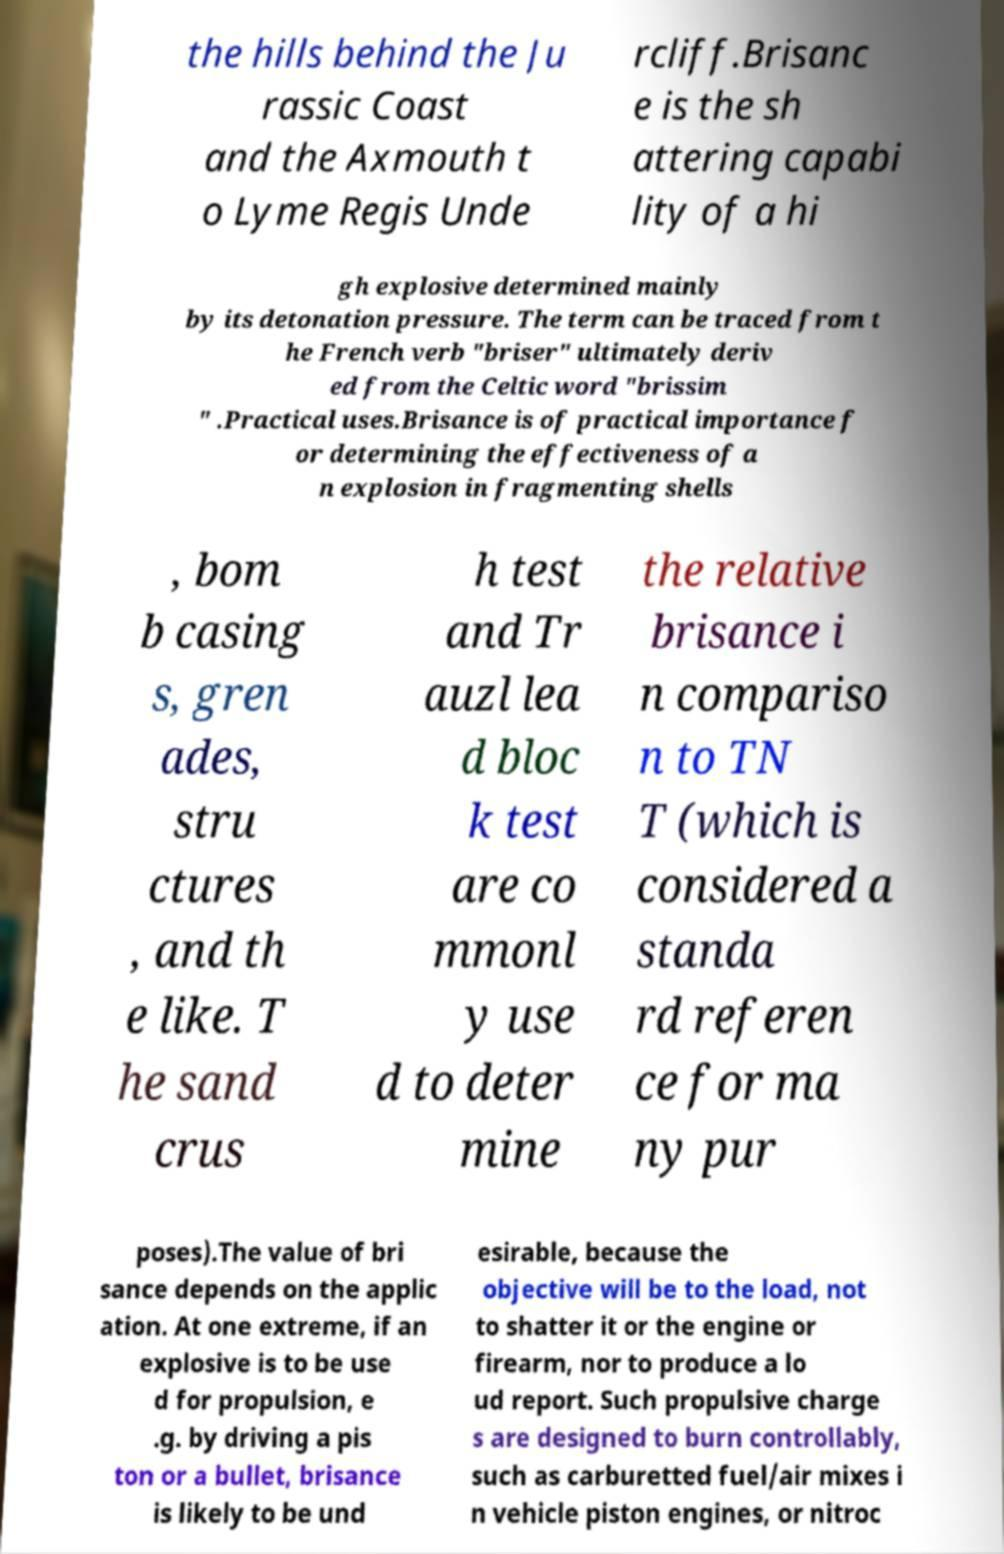Could you assist in decoding the text presented in this image and type it out clearly? the hills behind the Ju rassic Coast and the Axmouth t o Lyme Regis Unde rcliff.Brisanc e is the sh attering capabi lity of a hi gh explosive determined mainly by its detonation pressure. The term can be traced from t he French verb "briser" ultimately deriv ed from the Celtic word "brissim " .Practical uses.Brisance is of practical importance f or determining the effectiveness of a n explosion in fragmenting shells , bom b casing s, gren ades, stru ctures , and th e like. T he sand crus h test and Tr auzl lea d bloc k test are co mmonl y use d to deter mine the relative brisance i n compariso n to TN T (which is considered a standa rd referen ce for ma ny pur poses).The value of bri sance depends on the applic ation. At one extreme, if an explosive is to be use d for propulsion, e .g. by driving a pis ton or a bullet, brisance is likely to be und esirable, because the objective will be to the load, not to shatter it or the engine or firearm, nor to produce a lo ud report. Such propulsive charge s are designed to burn controllably, such as carburetted fuel/air mixes i n vehicle piston engines, or nitroc 